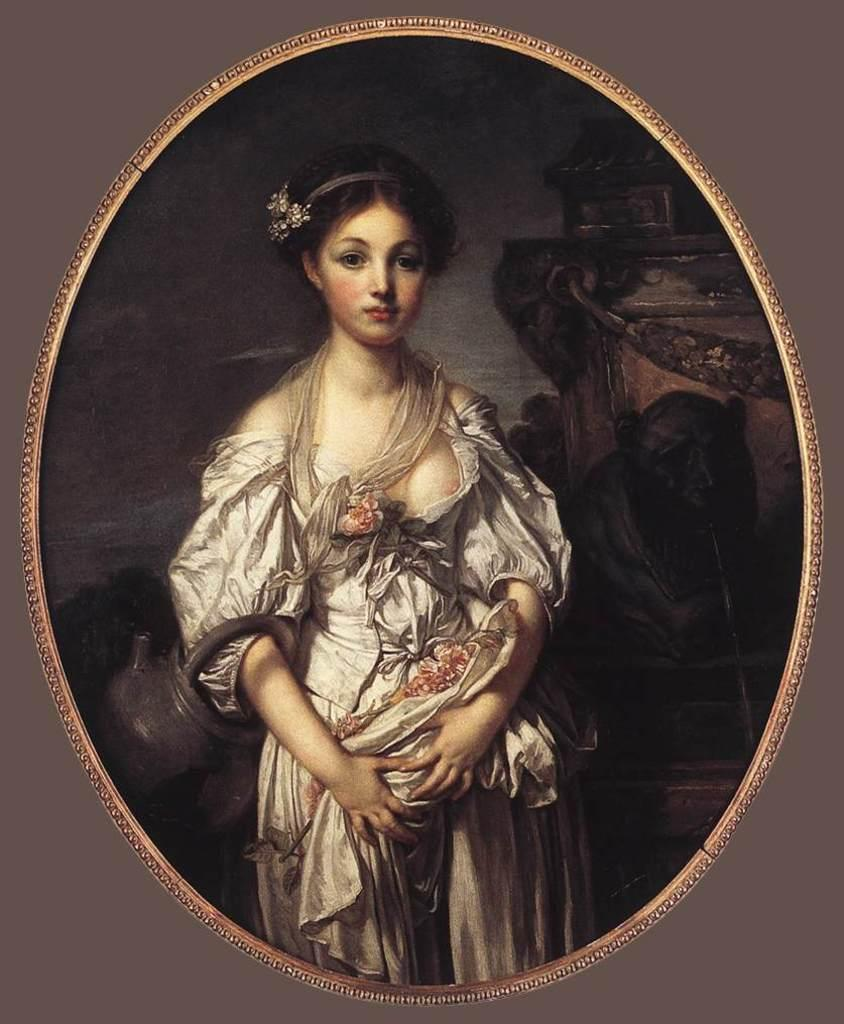What is present in the image? There is a poster in the image. What can be seen on the poster? The poster contains an image of a woman. What type of brick is used to build the school in the image? There is no school or brick present in the image; it only features a poster with an image of a woman. 